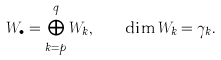<formula> <loc_0><loc_0><loc_500><loc_500>W _ { \bullet } = \bigoplus _ { k = p } ^ { q } W _ { k } , \quad \dim W _ { k } = \gamma _ { k } .</formula> 